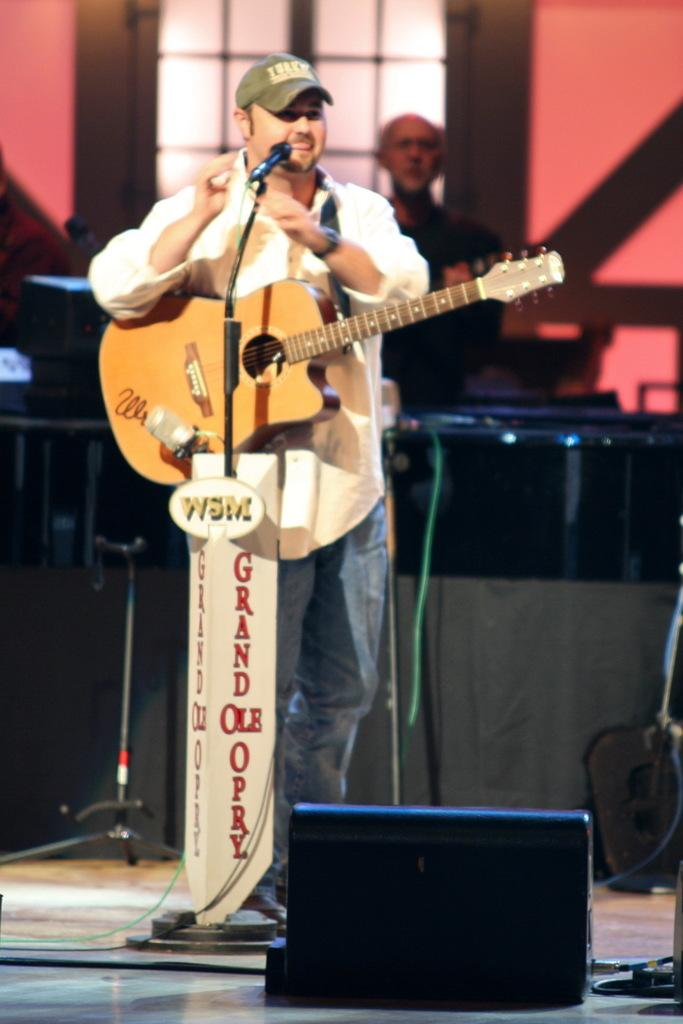What is the man in the image holding? The man is holding a guitar. What is the man standing in front of in the image? The man is standing in front of a microphone. Can you describe the background of the image? There is a person visible in a window in the background of the image. What type of feeling can be seen on the man's face in the image? The image does not convey any specific feelings or emotions on the man's face, as it is a still image. 